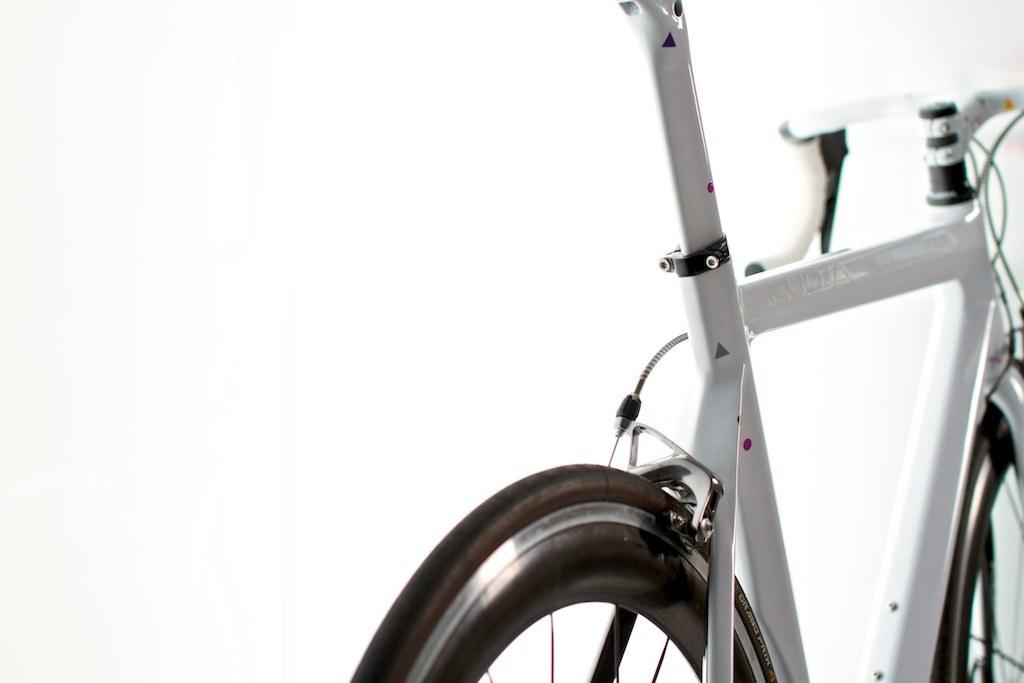What object is partially visible in the image? There is a part of a bicycle in the image. What can be inferred about the color of the bicycle part? The bicycle part is white in color. Where is the nest of the bird located in the image? There is no nest or bird present in the image; it only features a part of a bicycle. 